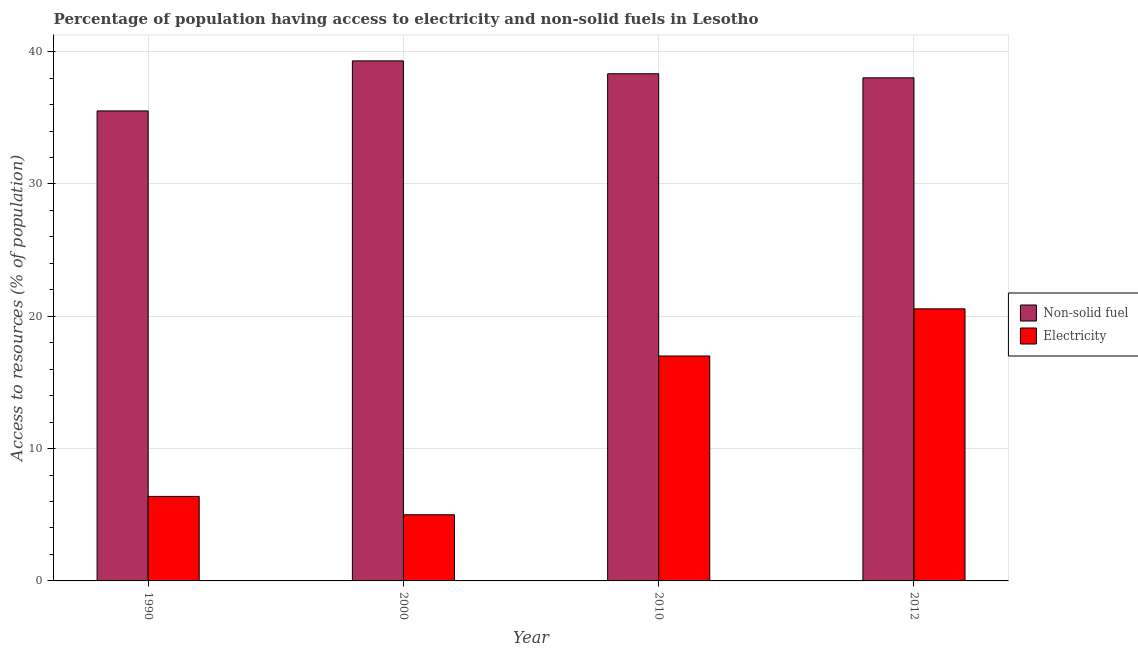How many different coloured bars are there?
Provide a succinct answer. 2. How many groups of bars are there?
Offer a terse response. 4. Are the number of bars per tick equal to the number of legend labels?
Give a very brief answer. Yes. What is the percentage of population having access to non-solid fuel in 1990?
Your answer should be compact. 35.52. Across all years, what is the maximum percentage of population having access to non-solid fuel?
Provide a short and direct response. 39.3. Across all years, what is the minimum percentage of population having access to non-solid fuel?
Provide a short and direct response. 35.52. In which year was the percentage of population having access to electricity maximum?
Your answer should be compact. 2012. In which year was the percentage of population having access to non-solid fuel minimum?
Your answer should be very brief. 1990. What is the total percentage of population having access to electricity in the graph?
Give a very brief answer. 48.95. What is the difference between the percentage of population having access to non-solid fuel in 2000 and that in 2012?
Your answer should be very brief. 1.28. What is the difference between the percentage of population having access to electricity in 2012 and the percentage of population having access to non-solid fuel in 2010?
Offer a very short reply. 3.56. What is the average percentage of population having access to non-solid fuel per year?
Your response must be concise. 37.79. In the year 2000, what is the difference between the percentage of population having access to non-solid fuel and percentage of population having access to electricity?
Provide a succinct answer. 0. In how many years, is the percentage of population having access to non-solid fuel greater than 36 %?
Your answer should be very brief. 3. What is the ratio of the percentage of population having access to electricity in 1990 to that in 2012?
Ensure brevity in your answer.  0.31. What is the difference between the highest and the second highest percentage of population having access to electricity?
Your answer should be very brief. 3.56. What is the difference between the highest and the lowest percentage of population having access to non-solid fuel?
Make the answer very short. 3.78. In how many years, is the percentage of population having access to non-solid fuel greater than the average percentage of population having access to non-solid fuel taken over all years?
Offer a terse response. 3. What does the 1st bar from the left in 1990 represents?
Make the answer very short. Non-solid fuel. What does the 2nd bar from the right in 2012 represents?
Ensure brevity in your answer.  Non-solid fuel. How many bars are there?
Your response must be concise. 8. Are all the bars in the graph horizontal?
Your answer should be compact. No. How many years are there in the graph?
Give a very brief answer. 4. What is the difference between two consecutive major ticks on the Y-axis?
Provide a short and direct response. 10. Does the graph contain grids?
Give a very brief answer. Yes. Where does the legend appear in the graph?
Offer a very short reply. Center right. What is the title of the graph?
Provide a short and direct response. Percentage of population having access to electricity and non-solid fuels in Lesotho. What is the label or title of the X-axis?
Provide a short and direct response. Year. What is the label or title of the Y-axis?
Keep it short and to the point. Access to resources (% of population). What is the Access to resources (% of population) of Non-solid fuel in 1990?
Ensure brevity in your answer.  35.52. What is the Access to resources (% of population) in Electricity in 1990?
Provide a succinct answer. 6.39. What is the Access to resources (% of population) in Non-solid fuel in 2000?
Give a very brief answer. 39.3. What is the Access to resources (% of population) of Electricity in 2000?
Provide a succinct answer. 5. What is the Access to resources (% of population) of Non-solid fuel in 2010?
Offer a terse response. 38.33. What is the Access to resources (% of population) in Electricity in 2010?
Offer a terse response. 17. What is the Access to resources (% of population) of Non-solid fuel in 2012?
Give a very brief answer. 38.02. What is the Access to resources (% of population) in Electricity in 2012?
Provide a short and direct response. 20.56. Across all years, what is the maximum Access to resources (% of population) of Non-solid fuel?
Ensure brevity in your answer.  39.3. Across all years, what is the maximum Access to resources (% of population) in Electricity?
Your answer should be very brief. 20.56. Across all years, what is the minimum Access to resources (% of population) in Non-solid fuel?
Provide a short and direct response. 35.52. Across all years, what is the minimum Access to resources (% of population) in Electricity?
Your answer should be compact. 5. What is the total Access to resources (% of population) in Non-solid fuel in the graph?
Ensure brevity in your answer.  151.18. What is the total Access to resources (% of population) of Electricity in the graph?
Provide a succinct answer. 48.95. What is the difference between the Access to resources (% of population) in Non-solid fuel in 1990 and that in 2000?
Offer a very short reply. -3.78. What is the difference between the Access to resources (% of population) of Electricity in 1990 and that in 2000?
Provide a short and direct response. 1.39. What is the difference between the Access to resources (% of population) of Non-solid fuel in 1990 and that in 2010?
Your answer should be compact. -2.81. What is the difference between the Access to resources (% of population) of Electricity in 1990 and that in 2010?
Provide a short and direct response. -10.61. What is the difference between the Access to resources (% of population) of Non-solid fuel in 1990 and that in 2012?
Give a very brief answer. -2.5. What is the difference between the Access to resources (% of population) in Electricity in 1990 and that in 2012?
Ensure brevity in your answer.  -14.17. What is the difference between the Access to resources (% of population) in Non-solid fuel in 2000 and that in 2010?
Your answer should be compact. 0.97. What is the difference between the Access to resources (% of population) of Electricity in 2000 and that in 2010?
Ensure brevity in your answer.  -12. What is the difference between the Access to resources (% of population) in Non-solid fuel in 2000 and that in 2012?
Provide a short and direct response. 1.28. What is the difference between the Access to resources (% of population) in Electricity in 2000 and that in 2012?
Keep it short and to the point. -15.56. What is the difference between the Access to resources (% of population) in Non-solid fuel in 2010 and that in 2012?
Offer a terse response. 0.31. What is the difference between the Access to resources (% of population) of Electricity in 2010 and that in 2012?
Keep it short and to the point. -3.56. What is the difference between the Access to resources (% of population) of Non-solid fuel in 1990 and the Access to resources (% of population) of Electricity in 2000?
Your answer should be compact. 30.52. What is the difference between the Access to resources (% of population) in Non-solid fuel in 1990 and the Access to resources (% of population) in Electricity in 2010?
Provide a short and direct response. 18.52. What is the difference between the Access to resources (% of population) in Non-solid fuel in 1990 and the Access to resources (% of population) in Electricity in 2012?
Your answer should be compact. 14.96. What is the difference between the Access to resources (% of population) of Non-solid fuel in 2000 and the Access to resources (% of population) of Electricity in 2010?
Your response must be concise. 22.3. What is the difference between the Access to resources (% of population) of Non-solid fuel in 2000 and the Access to resources (% of population) of Electricity in 2012?
Your answer should be compact. 18.74. What is the difference between the Access to resources (% of population) of Non-solid fuel in 2010 and the Access to resources (% of population) of Electricity in 2012?
Keep it short and to the point. 17.77. What is the average Access to resources (% of population) in Non-solid fuel per year?
Keep it short and to the point. 37.79. What is the average Access to resources (% of population) of Electricity per year?
Your response must be concise. 12.24. In the year 1990, what is the difference between the Access to resources (% of population) in Non-solid fuel and Access to resources (% of population) in Electricity?
Provide a succinct answer. 29.13. In the year 2000, what is the difference between the Access to resources (% of population) in Non-solid fuel and Access to resources (% of population) in Electricity?
Make the answer very short. 34.3. In the year 2010, what is the difference between the Access to resources (% of population) in Non-solid fuel and Access to resources (% of population) in Electricity?
Ensure brevity in your answer.  21.33. In the year 2012, what is the difference between the Access to resources (% of population) of Non-solid fuel and Access to resources (% of population) of Electricity?
Make the answer very short. 17.46. What is the ratio of the Access to resources (% of population) of Non-solid fuel in 1990 to that in 2000?
Offer a terse response. 0.9. What is the ratio of the Access to resources (% of population) in Electricity in 1990 to that in 2000?
Give a very brief answer. 1.28. What is the ratio of the Access to resources (% of population) in Non-solid fuel in 1990 to that in 2010?
Ensure brevity in your answer.  0.93. What is the ratio of the Access to resources (% of population) of Electricity in 1990 to that in 2010?
Your answer should be very brief. 0.38. What is the ratio of the Access to resources (% of population) of Non-solid fuel in 1990 to that in 2012?
Keep it short and to the point. 0.93. What is the ratio of the Access to resources (% of population) in Electricity in 1990 to that in 2012?
Give a very brief answer. 0.31. What is the ratio of the Access to resources (% of population) in Non-solid fuel in 2000 to that in 2010?
Provide a short and direct response. 1.03. What is the ratio of the Access to resources (% of population) of Electricity in 2000 to that in 2010?
Offer a terse response. 0.29. What is the ratio of the Access to resources (% of population) of Non-solid fuel in 2000 to that in 2012?
Offer a terse response. 1.03. What is the ratio of the Access to resources (% of population) of Electricity in 2000 to that in 2012?
Make the answer very short. 0.24. What is the ratio of the Access to resources (% of population) of Electricity in 2010 to that in 2012?
Provide a short and direct response. 0.83. What is the difference between the highest and the second highest Access to resources (% of population) of Non-solid fuel?
Provide a succinct answer. 0.97. What is the difference between the highest and the second highest Access to resources (% of population) in Electricity?
Your answer should be compact. 3.56. What is the difference between the highest and the lowest Access to resources (% of population) in Non-solid fuel?
Provide a succinct answer. 3.78. What is the difference between the highest and the lowest Access to resources (% of population) of Electricity?
Provide a short and direct response. 15.56. 